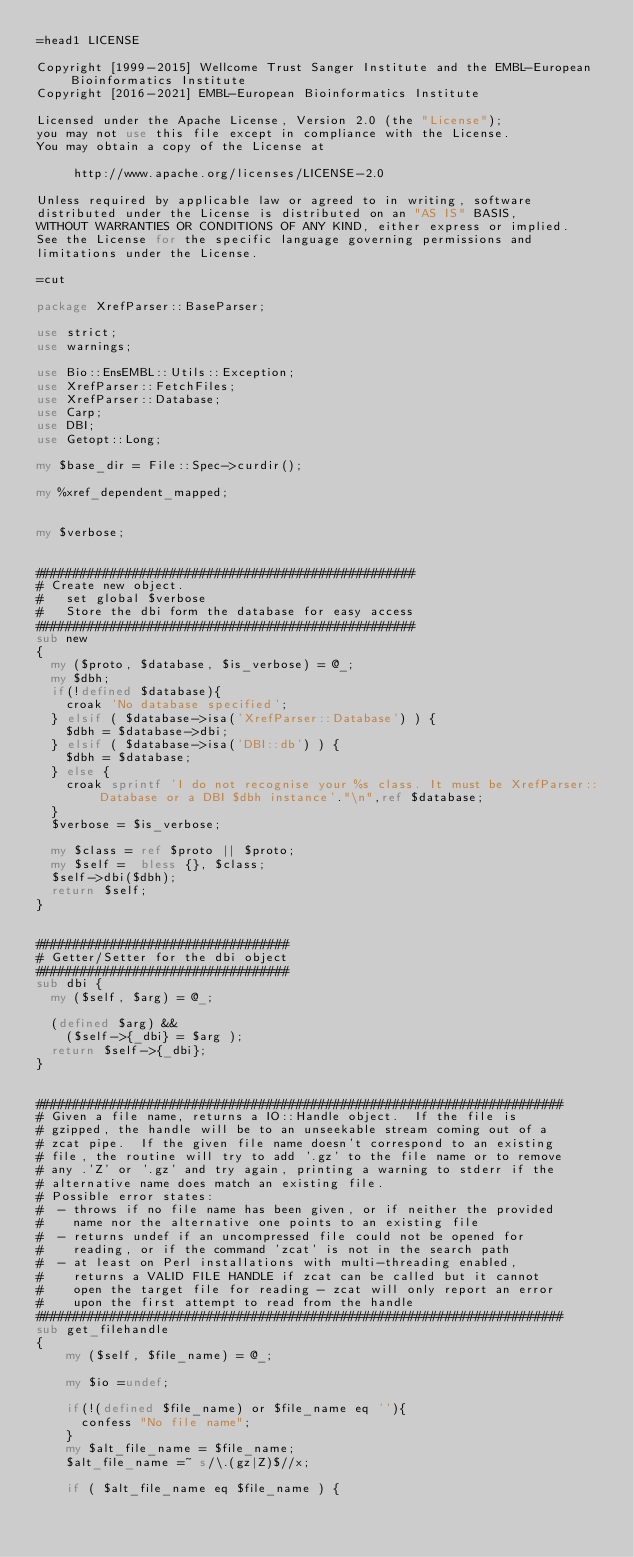<code> <loc_0><loc_0><loc_500><loc_500><_Perl_>=head1 LICENSE

Copyright [1999-2015] Wellcome Trust Sanger Institute and the EMBL-European Bioinformatics Institute
Copyright [2016-2021] EMBL-European Bioinformatics Institute

Licensed under the Apache License, Version 2.0 (the "License");
you may not use this file except in compliance with the License.
You may obtain a copy of the License at

     http://www.apache.org/licenses/LICENSE-2.0

Unless required by applicable law or agreed to in writing, software
distributed under the License is distributed on an "AS IS" BASIS,
WITHOUT WARRANTIES OR CONDITIONS OF ANY KIND, either express or implied.
See the License for the specific language governing permissions and
limitations under the License.

=cut

package XrefParser::BaseParser;

use strict;
use warnings;

use Bio::EnsEMBL::Utils::Exception;
use XrefParser::FetchFiles;
use XrefParser::Database;
use Carp;
use DBI;
use Getopt::Long;

my $base_dir = File::Spec->curdir();

my %xref_dependent_mapped;


my $verbose;


###################################################
# Create new object.
#   set global $verbose
#   Store the dbi form the database for easy access
###################################################
sub new
{
  my ($proto, $database, $is_verbose) = @_;
  my $dbh;
  if(!defined $database){
    croak 'No database specified';
  } elsif ( $database->isa('XrefParser::Database') ) {
    $dbh = $database->dbi;
  } elsif ( $database->isa('DBI::db') ) {
    $dbh = $database;
  } else {
    croak sprintf 'I do not recognise your %s class. It must be XrefParser::Database or a DBI $dbh instance'."\n",ref $database;
  }
  $verbose = $is_verbose;

  my $class = ref $proto || $proto;
  my $self =  bless {}, $class;
  $self->dbi($dbh);
  return $self;
}


##################################
# Getter/Setter for the dbi object
##################################
sub dbi {
  my ($self, $arg) = @_;

  (defined $arg) &&
    ($self->{_dbi} = $arg );
  return $self->{_dbi};
}


#######################################################################
# Given a file name, returns a IO::Handle object.  If the file is
# gzipped, the handle will be to an unseekable stream coming out of a
# zcat pipe.  If the given file name doesn't correspond to an existing
# file, the routine will try to add '.gz' to the file name or to remove
# any .'Z' or '.gz' and try again, printing a warning to stderr if the
# alternative name does match an existing file.
# Possible error states:
#  - throws if no file name has been given, or if neither the provided
#    name nor the alternative one points to an existing file
#  - returns undef if an uncompressed file could not be opened for
#    reading, or if the command 'zcat' is not in the search path
#  - at least on Perl installations with multi-threading enabled,
#    returns a VALID FILE HANDLE if zcat can be called but it cannot
#    open the target file for reading - zcat will only report an error
#    upon the first attempt to read from the handle
#######################################################################
sub get_filehandle
{
    my ($self, $file_name) = @_;

    my $io =undef;

    if(!(defined $file_name) or $file_name eq ''){
      confess "No file name";
    }
    my $alt_file_name = $file_name;
    $alt_file_name =~ s/\.(gz|Z)$//x;

    if ( $alt_file_name eq $file_name ) {</code> 